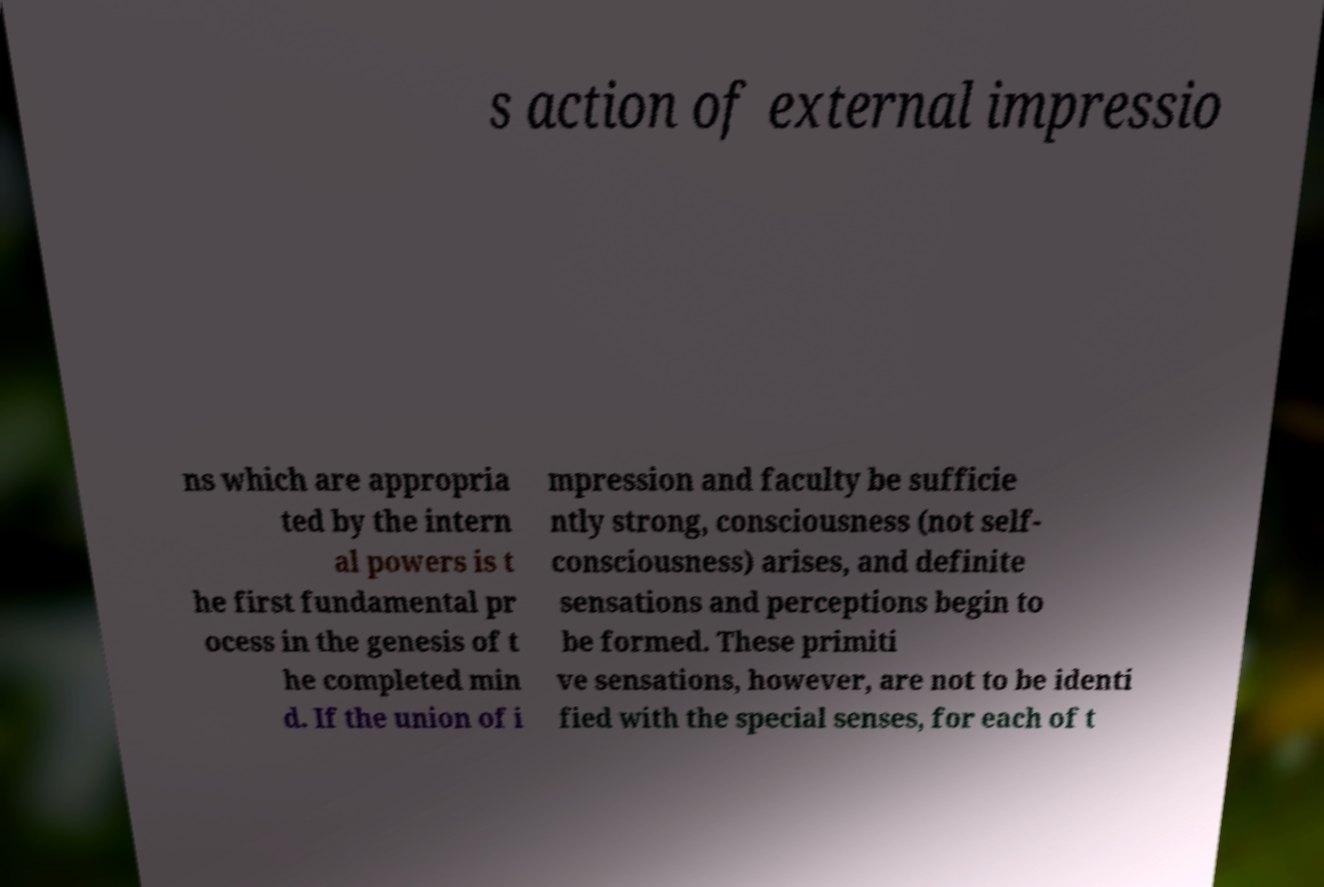What messages or text are displayed in this image? I need them in a readable, typed format. s action of external impressio ns which are appropria ted by the intern al powers is t he first fundamental pr ocess in the genesis of t he completed min d. If the union of i mpression and faculty be sufficie ntly strong, consciousness (not self- consciousness) arises, and definite sensations and perceptions begin to be formed. These primiti ve sensations, however, are not to be identi fied with the special senses, for each of t 